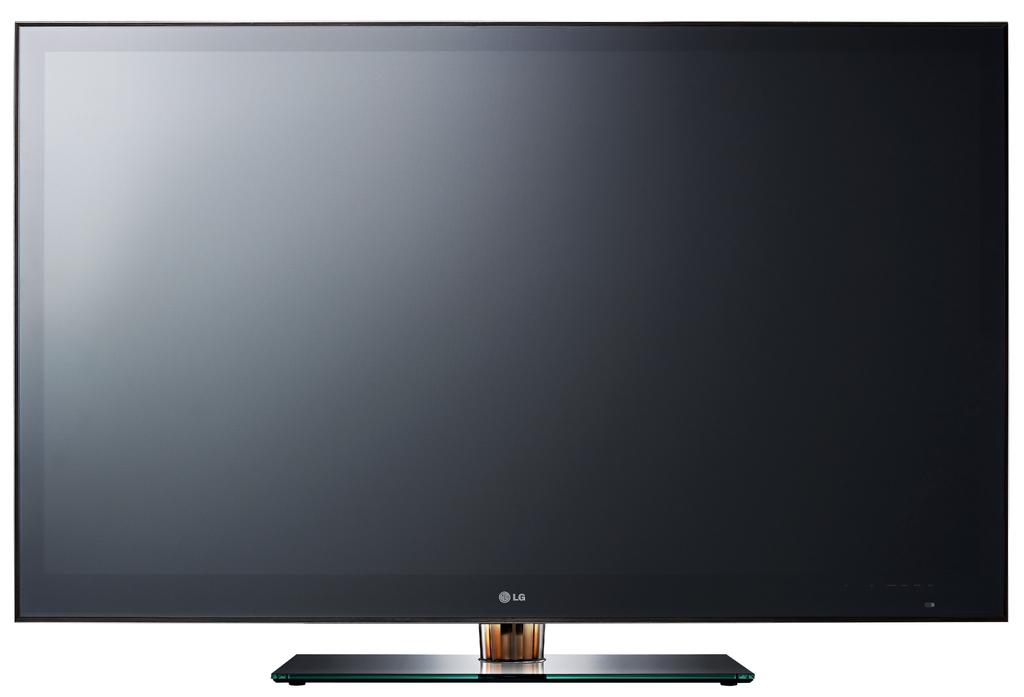<image>
Render a clear and concise summary of the photo. A picture of a LG television against a white backdrop. 